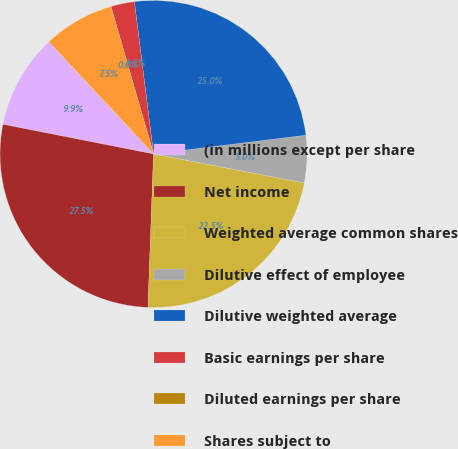<chart> <loc_0><loc_0><loc_500><loc_500><pie_chart><fcel>(in millions except per share<fcel>Net income<fcel>Weighted average common shares<fcel>Dilutive effect of employee<fcel>Dilutive weighted average<fcel>Basic earnings per share<fcel>Diluted earnings per share<fcel>Shares subject to<nl><fcel>9.95%<fcel>27.52%<fcel>22.55%<fcel>4.98%<fcel>25.04%<fcel>2.49%<fcel>0.0%<fcel>7.47%<nl></chart> 